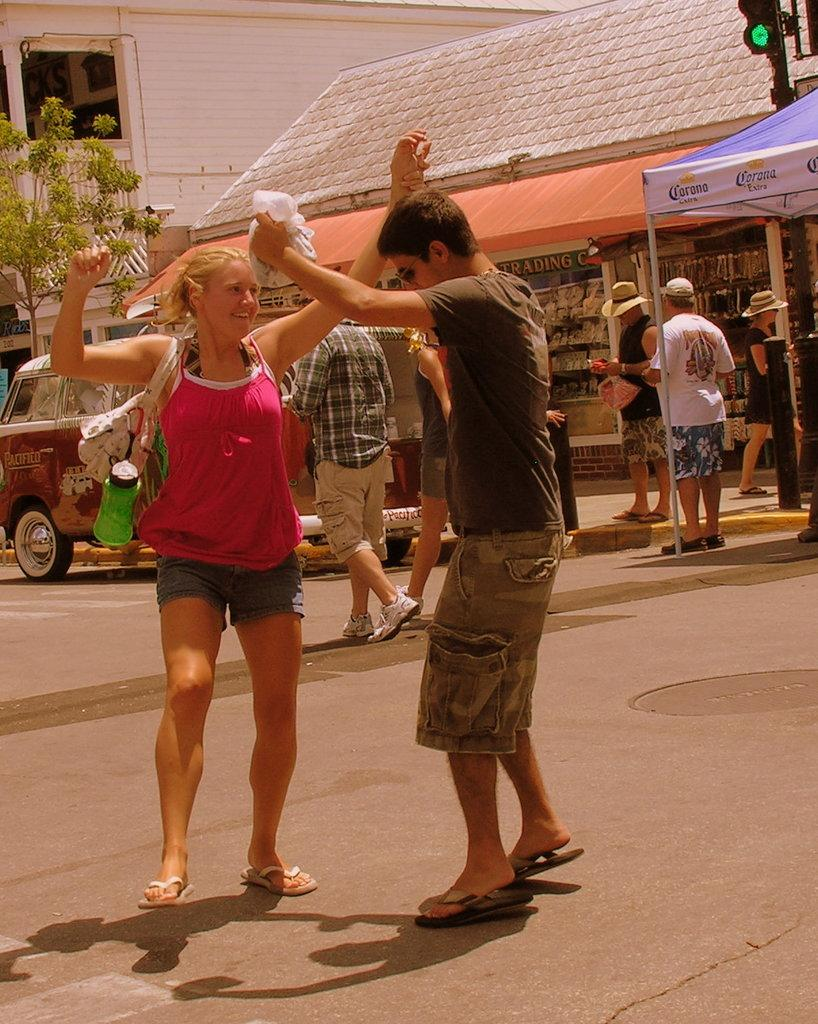What is happening at the bottom side of the image? There are people at the bottom side of the image. What is the person on the stage doing? The person on the stage is holding a guitar. Can you describe the other person in the image? There is another person in the image, but their actions or appearance are not specified. What can be seen in the background of the image? There are microphones in the background of the image. What type of lunch is being served at the event in the image? There is no indication of a lunch or any food being served in the image. Can you tell me how many popcorn kernels are visible in the image? There is no popcorn present in the image. 